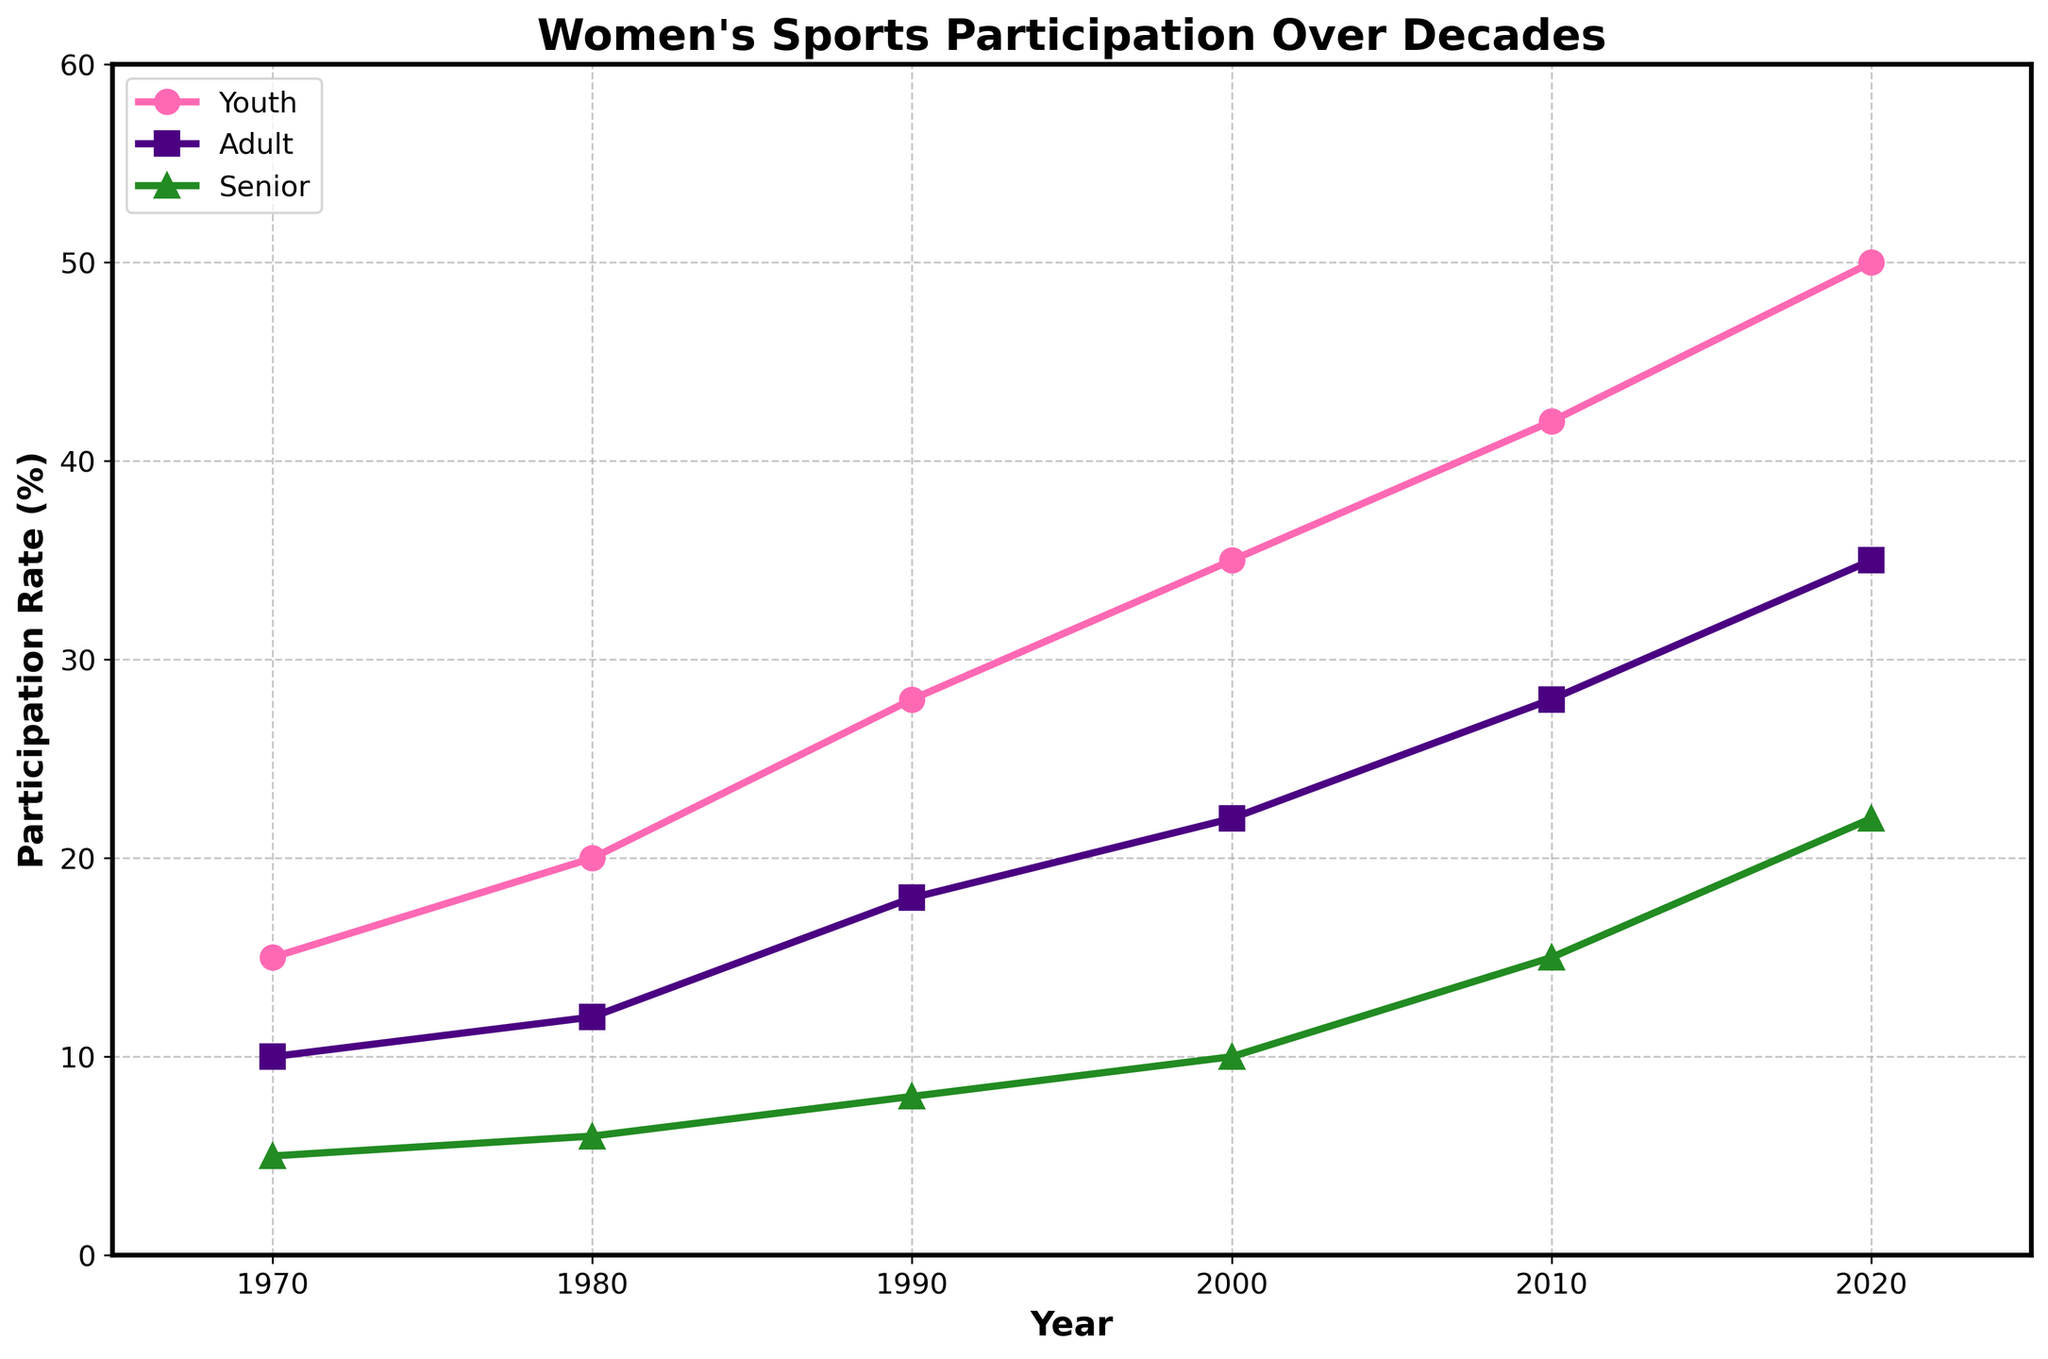What is the title of the figure? The title is usually found at the top of the figure and it provides a brief description of the content or what the figure represents.
Answer: Women's Sports Participation Over Decades What is the participation rate for adults in 2010? To find this, locate the year 2010 on the x-axis and check the corresponding value for adults in the plot which is marked by a square (s) symbol.
Answer: 28% By how much did the senior participation rate increase from 2000 to 2020? To determine the increase, subtract the senior participation rate in 2000 from the senior participation rate in 2020: 22 - 10 = 12%.
Answer: 12% Which age group had the highest participation rate in 2020? Look at the endpoints of all the lines (youth, adult, and senior) for the year 2020 and compare the values.
Answer: Youth On average, by how much did the youth participation rate increase each decade from 1970 to 2020? The youth participation rate increased from 15% in 1970 to 50% in 2020, over 5 decades. The average increase per decade is (50 - 15) / 5 = 7%.
Answer: 7% What is the overall trend observed in the senior participation rate over the decades? Check the progression of the green line (triangle symbol) from 1970 to 2020. The senior participation rate shows a steady upward trend.
Answer: Increasing Which year shows the lowest participation rate across all age groups? Identify the lowest values for all three groups and check which year corresponds to these values.
Answer: 1970 By how much did the adult participation rate increase between the decades of 1990 and 2000? Subtract the adult participation rate in 1990 from the rate in 2000: 22% - 18% = 4%.
Answer: 4% Is the growth rate in the youth participation rate faster or slower than that of the senior participation rate over the entire period? Calculate the overall increase for both groups and compare: Youth: 50-15 = 35%; Senior: 22-5 = 17%. Since 35% > 17%, youth participation grew faster.
Answer: Faster By what percentage did the youth participation rate increase from 1980 to 1990, and how does it compare to the increase from 1990 to 2000? Calculate the increase for both periods: 1980-1990: 28-20 = 8%; 1990-2000: 35-28 = 7%. 8% > 7%, so the increase was higher from 1980 to 1990.
Answer: Higher from 1980 to 1990 